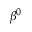Convert formula to latex. <formula><loc_0><loc_0><loc_500><loc_500>\beta ^ { 0 }</formula> 